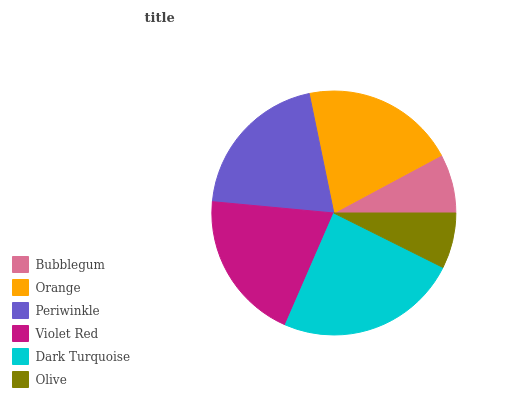Is Olive the minimum?
Answer yes or no. Yes. Is Dark Turquoise the maximum?
Answer yes or no. Yes. Is Orange the minimum?
Answer yes or no. No. Is Orange the maximum?
Answer yes or no. No. Is Orange greater than Bubblegum?
Answer yes or no. Yes. Is Bubblegum less than Orange?
Answer yes or no. Yes. Is Bubblegum greater than Orange?
Answer yes or no. No. Is Orange less than Bubblegum?
Answer yes or no. No. Is Periwinkle the high median?
Answer yes or no. Yes. Is Violet Red the low median?
Answer yes or no. Yes. Is Violet Red the high median?
Answer yes or no. No. Is Dark Turquoise the low median?
Answer yes or no. No. 